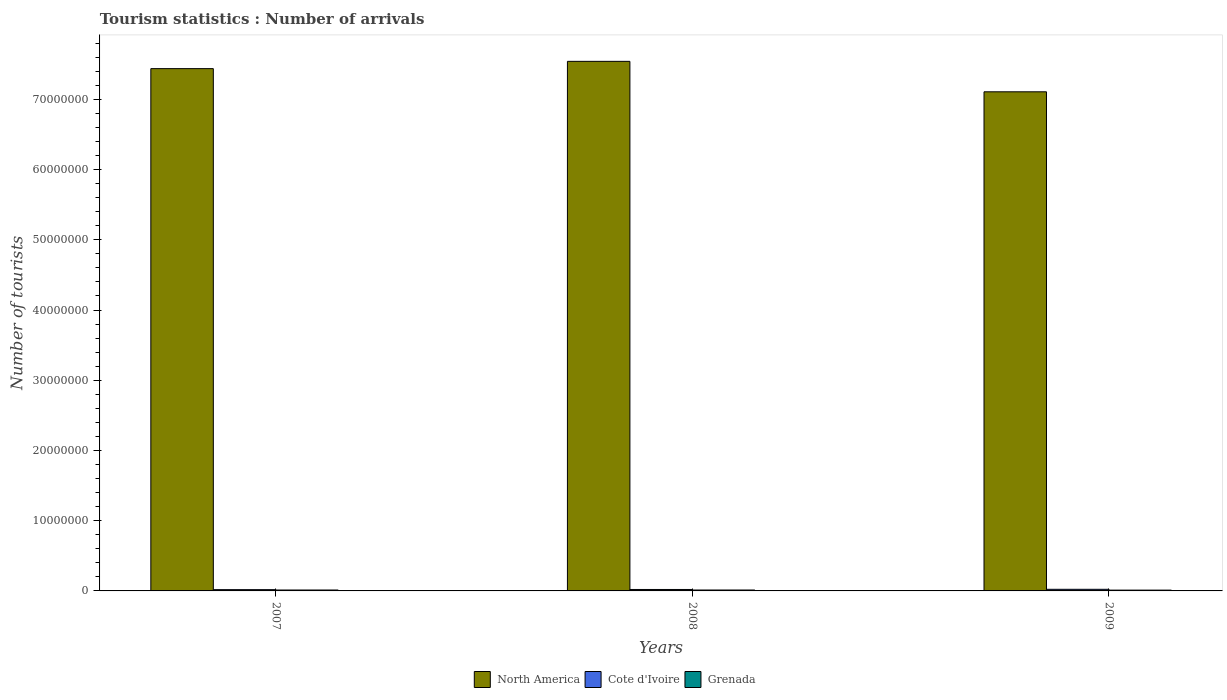How many different coloured bars are there?
Give a very brief answer. 3. How many groups of bars are there?
Your answer should be compact. 3. Are the number of bars per tick equal to the number of legend labels?
Your answer should be very brief. Yes. How many bars are there on the 1st tick from the left?
Offer a very short reply. 3. What is the number of tourist arrivals in North America in 2009?
Keep it short and to the point. 7.11e+07. Across all years, what is the maximum number of tourist arrivals in Grenada?
Offer a terse response. 1.30e+05. Across all years, what is the minimum number of tourist arrivals in Cote d'Ivoire?
Your answer should be very brief. 1.82e+05. In which year was the number of tourist arrivals in North America maximum?
Make the answer very short. 2008. In which year was the number of tourist arrivals in Cote d'Ivoire minimum?
Keep it short and to the point. 2007. What is the total number of tourist arrivals in Cote d'Ivoire in the graph?
Make the answer very short. 6.18e+05. What is the difference between the number of tourist arrivals in Cote d'Ivoire in 2008 and that in 2009?
Your answer should be compact. -2.60e+04. What is the difference between the number of tourist arrivals in Cote d'Ivoire in 2007 and the number of tourist arrivals in North America in 2009?
Make the answer very short. -7.09e+07. What is the average number of tourist arrivals in Cote d'Ivoire per year?
Offer a very short reply. 2.06e+05. In the year 2007, what is the difference between the number of tourist arrivals in North America and number of tourist arrivals in Cote d'Ivoire?
Make the answer very short. 7.42e+07. In how many years, is the number of tourist arrivals in Grenada greater than 70000000?
Offer a very short reply. 0. What is the ratio of the number of tourist arrivals in North America in 2008 to that in 2009?
Your response must be concise. 1.06. Is the difference between the number of tourist arrivals in North America in 2007 and 2009 greater than the difference between the number of tourist arrivals in Cote d'Ivoire in 2007 and 2009?
Offer a very short reply. Yes. What is the difference between the highest and the second highest number of tourist arrivals in Cote d'Ivoire?
Offer a very short reply. 2.60e+04. What is the difference between the highest and the lowest number of tourist arrivals in Cote d'Ivoire?
Provide a short and direct response. 4.90e+04. Is the sum of the number of tourist arrivals in Cote d'Ivoire in 2008 and 2009 greater than the maximum number of tourist arrivals in Grenada across all years?
Ensure brevity in your answer.  Yes. What does the 3rd bar from the left in 2009 represents?
Your response must be concise. Grenada. What does the 1st bar from the right in 2008 represents?
Keep it short and to the point. Grenada. Is it the case that in every year, the sum of the number of tourist arrivals in Cote d'Ivoire and number of tourist arrivals in Grenada is greater than the number of tourist arrivals in North America?
Offer a terse response. No. What is the difference between two consecutive major ticks on the Y-axis?
Your response must be concise. 1.00e+07. How are the legend labels stacked?
Make the answer very short. Horizontal. What is the title of the graph?
Your answer should be compact. Tourism statistics : Number of arrivals. Does "Belize" appear as one of the legend labels in the graph?
Your answer should be very brief. No. What is the label or title of the Y-axis?
Provide a short and direct response. Number of tourists. What is the Number of tourists of North America in 2007?
Offer a terse response. 7.44e+07. What is the Number of tourists of Cote d'Ivoire in 2007?
Offer a terse response. 1.82e+05. What is the Number of tourists in Grenada in 2007?
Keep it short and to the point. 1.30e+05. What is the Number of tourists of North America in 2008?
Provide a short and direct response. 7.54e+07. What is the Number of tourists in Cote d'Ivoire in 2008?
Your answer should be very brief. 2.05e+05. What is the Number of tourists of Grenada in 2008?
Provide a succinct answer. 1.30e+05. What is the Number of tourists of North America in 2009?
Your answer should be very brief. 7.11e+07. What is the Number of tourists of Cote d'Ivoire in 2009?
Keep it short and to the point. 2.31e+05. What is the Number of tourists of Grenada in 2009?
Give a very brief answer. 1.14e+05. Across all years, what is the maximum Number of tourists of North America?
Give a very brief answer. 7.54e+07. Across all years, what is the maximum Number of tourists in Cote d'Ivoire?
Keep it short and to the point. 2.31e+05. Across all years, what is the minimum Number of tourists in North America?
Ensure brevity in your answer.  7.11e+07. Across all years, what is the minimum Number of tourists of Cote d'Ivoire?
Keep it short and to the point. 1.82e+05. Across all years, what is the minimum Number of tourists in Grenada?
Make the answer very short. 1.14e+05. What is the total Number of tourists of North America in the graph?
Your response must be concise. 2.21e+08. What is the total Number of tourists of Cote d'Ivoire in the graph?
Your response must be concise. 6.18e+05. What is the total Number of tourists of Grenada in the graph?
Ensure brevity in your answer.  3.74e+05. What is the difference between the Number of tourists in North America in 2007 and that in 2008?
Make the answer very short. -1.04e+06. What is the difference between the Number of tourists in Cote d'Ivoire in 2007 and that in 2008?
Offer a terse response. -2.30e+04. What is the difference between the Number of tourists of North America in 2007 and that in 2009?
Your answer should be very brief. 3.30e+06. What is the difference between the Number of tourists in Cote d'Ivoire in 2007 and that in 2009?
Your answer should be very brief. -4.90e+04. What is the difference between the Number of tourists of Grenada in 2007 and that in 2009?
Make the answer very short. 1.60e+04. What is the difference between the Number of tourists in North America in 2008 and that in 2009?
Offer a very short reply. 4.34e+06. What is the difference between the Number of tourists in Cote d'Ivoire in 2008 and that in 2009?
Your answer should be compact. -2.60e+04. What is the difference between the Number of tourists in Grenada in 2008 and that in 2009?
Provide a succinct answer. 1.60e+04. What is the difference between the Number of tourists in North America in 2007 and the Number of tourists in Cote d'Ivoire in 2008?
Your response must be concise. 7.42e+07. What is the difference between the Number of tourists of North America in 2007 and the Number of tourists of Grenada in 2008?
Offer a very short reply. 7.42e+07. What is the difference between the Number of tourists in Cote d'Ivoire in 2007 and the Number of tourists in Grenada in 2008?
Your answer should be compact. 5.20e+04. What is the difference between the Number of tourists of North America in 2007 and the Number of tourists of Cote d'Ivoire in 2009?
Give a very brief answer. 7.41e+07. What is the difference between the Number of tourists of North America in 2007 and the Number of tourists of Grenada in 2009?
Your answer should be compact. 7.43e+07. What is the difference between the Number of tourists in Cote d'Ivoire in 2007 and the Number of tourists in Grenada in 2009?
Keep it short and to the point. 6.80e+04. What is the difference between the Number of tourists of North America in 2008 and the Number of tourists of Cote d'Ivoire in 2009?
Your response must be concise. 7.52e+07. What is the difference between the Number of tourists of North America in 2008 and the Number of tourists of Grenada in 2009?
Provide a succinct answer. 7.53e+07. What is the difference between the Number of tourists in Cote d'Ivoire in 2008 and the Number of tourists in Grenada in 2009?
Offer a terse response. 9.10e+04. What is the average Number of tourists of North America per year?
Keep it short and to the point. 7.36e+07. What is the average Number of tourists in Cote d'Ivoire per year?
Ensure brevity in your answer.  2.06e+05. What is the average Number of tourists in Grenada per year?
Offer a terse response. 1.25e+05. In the year 2007, what is the difference between the Number of tourists of North America and Number of tourists of Cote d'Ivoire?
Your answer should be very brief. 7.42e+07. In the year 2007, what is the difference between the Number of tourists of North America and Number of tourists of Grenada?
Give a very brief answer. 7.42e+07. In the year 2007, what is the difference between the Number of tourists in Cote d'Ivoire and Number of tourists in Grenada?
Ensure brevity in your answer.  5.20e+04. In the year 2008, what is the difference between the Number of tourists of North America and Number of tourists of Cote d'Ivoire?
Keep it short and to the point. 7.52e+07. In the year 2008, what is the difference between the Number of tourists of North America and Number of tourists of Grenada?
Offer a terse response. 7.53e+07. In the year 2008, what is the difference between the Number of tourists in Cote d'Ivoire and Number of tourists in Grenada?
Ensure brevity in your answer.  7.50e+04. In the year 2009, what is the difference between the Number of tourists of North America and Number of tourists of Cote d'Ivoire?
Ensure brevity in your answer.  7.08e+07. In the year 2009, what is the difference between the Number of tourists in North America and Number of tourists in Grenada?
Your response must be concise. 7.10e+07. In the year 2009, what is the difference between the Number of tourists of Cote d'Ivoire and Number of tourists of Grenada?
Your answer should be compact. 1.17e+05. What is the ratio of the Number of tourists in North America in 2007 to that in 2008?
Your response must be concise. 0.99. What is the ratio of the Number of tourists of Cote d'Ivoire in 2007 to that in 2008?
Give a very brief answer. 0.89. What is the ratio of the Number of tourists in North America in 2007 to that in 2009?
Your response must be concise. 1.05. What is the ratio of the Number of tourists in Cote d'Ivoire in 2007 to that in 2009?
Ensure brevity in your answer.  0.79. What is the ratio of the Number of tourists in Grenada in 2007 to that in 2009?
Offer a terse response. 1.14. What is the ratio of the Number of tourists of North America in 2008 to that in 2009?
Keep it short and to the point. 1.06. What is the ratio of the Number of tourists of Cote d'Ivoire in 2008 to that in 2009?
Your response must be concise. 0.89. What is the ratio of the Number of tourists in Grenada in 2008 to that in 2009?
Offer a terse response. 1.14. What is the difference between the highest and the second highest Number of tourists in North America?
Provide a succinct answer. 1.04e+06. What is the difference between the highest and the second highest Number of tourists of Cote d'Ivoire?
Offer a terse response. 2.60e+04. What is the difference between the highest and the lowest Number of tourists of North America?
Provide a succinct answer. 4.34e+06. What is the difference between the highest and the lowest Number of tourists of Cote d'Ivoire?
Your response must be concise. 4.90e+04. What is the difference between the highest and the lowest Number of tourists in Grenada?
Offer a very short reply. 1.60e+04. 